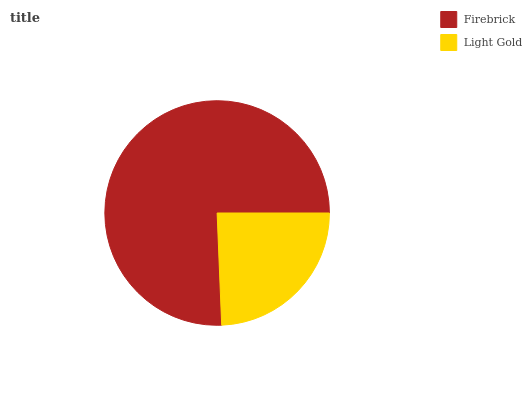Is Light Gold the minimum?
Answer yes or no. Yes. Is Firebrick the maximum?
Answer yes or no. Yes. Is Light Gold the maximum?
Answer yes or no. No. Is Firebrick greater than Light Gold?
Answer yes or no. Yes. Is Light Gold less than Firebrick?
Answer yes or no. Yes. Is Light Gold greater than Firebrick?
Answer yes or no. No. Is Firebrick less than Light Gold?
Answer yes or no. No. Is Firebrick the high median?
Answer yes or no. Yes. Is Light Gold the low median?
Answer yes or no. Yes. Is Light Gold the high median?
Answer yes or no. No. Is Firebrick the low median?
Answer yes or no. No. 